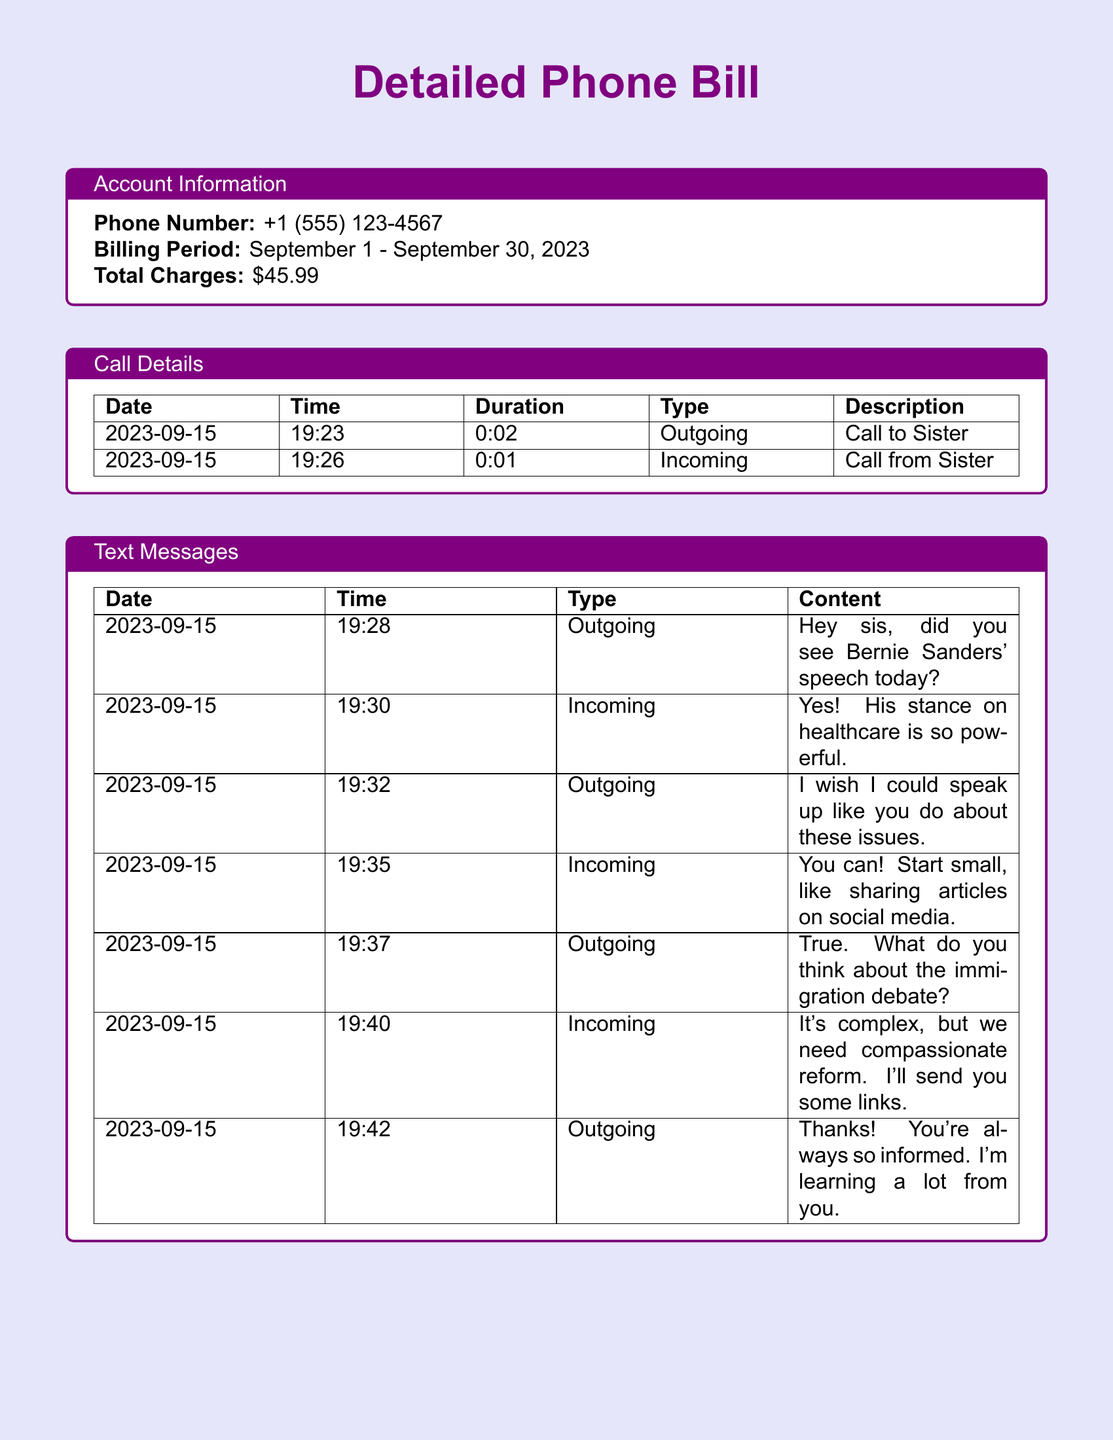What is the phone number? The phone number listed in the account information section is provided directly.
Answer: +1 (555) 123-4567 What is the billing period? The billing period is mentioned in the account information and specifies the start and end date.
Answer: September 1 - September 30, 2023 How many texts were exchanged with sister on September 15? By counting the entries under 'Text Messages', we can see the total number of messages exchanged.
Answer: 6 What did the sister say about the immigration debate? The sister's response regarding the immigration debate is present in the document and can be directly extracted.
Answer: It's complex, but we need compassionate reform What type of message was sent at 19:28? The type of message is specified next to the time in the 'Text Messages' section.
Answer: Outgoing What is the total data usage? The total data usage is provided in the Data Usage section of the document.
Answer: 2.3 GB 